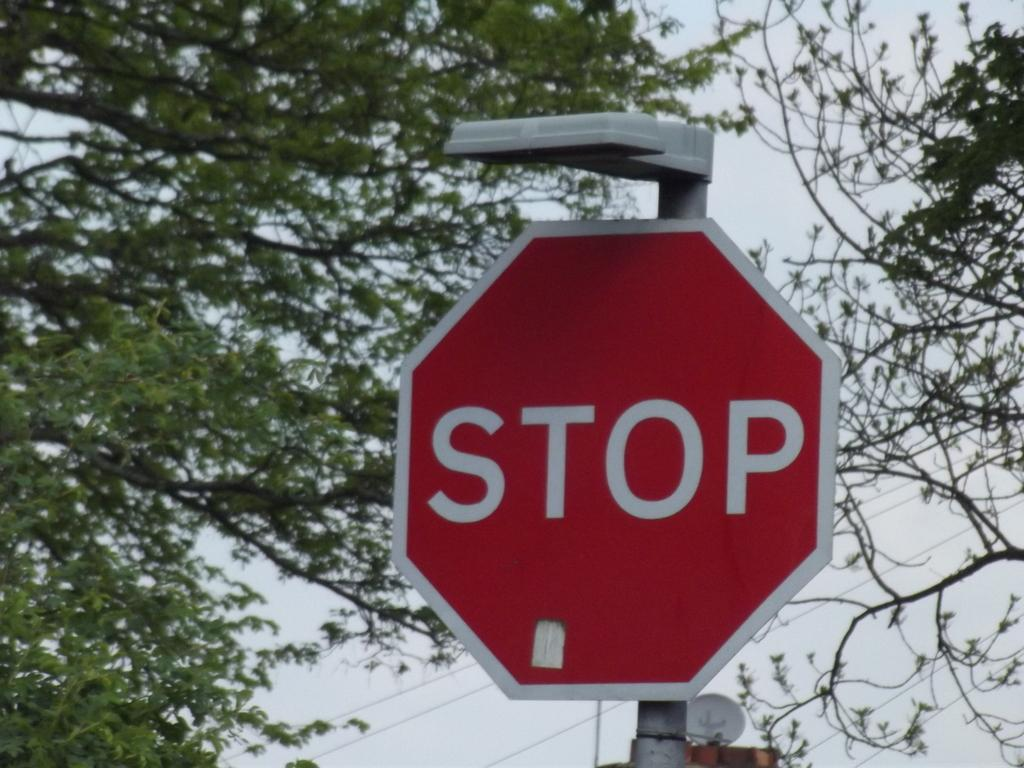<image>
Share a concise interpretation of the image provided. A red sign that says Stop in a city neighborhood with trees. 